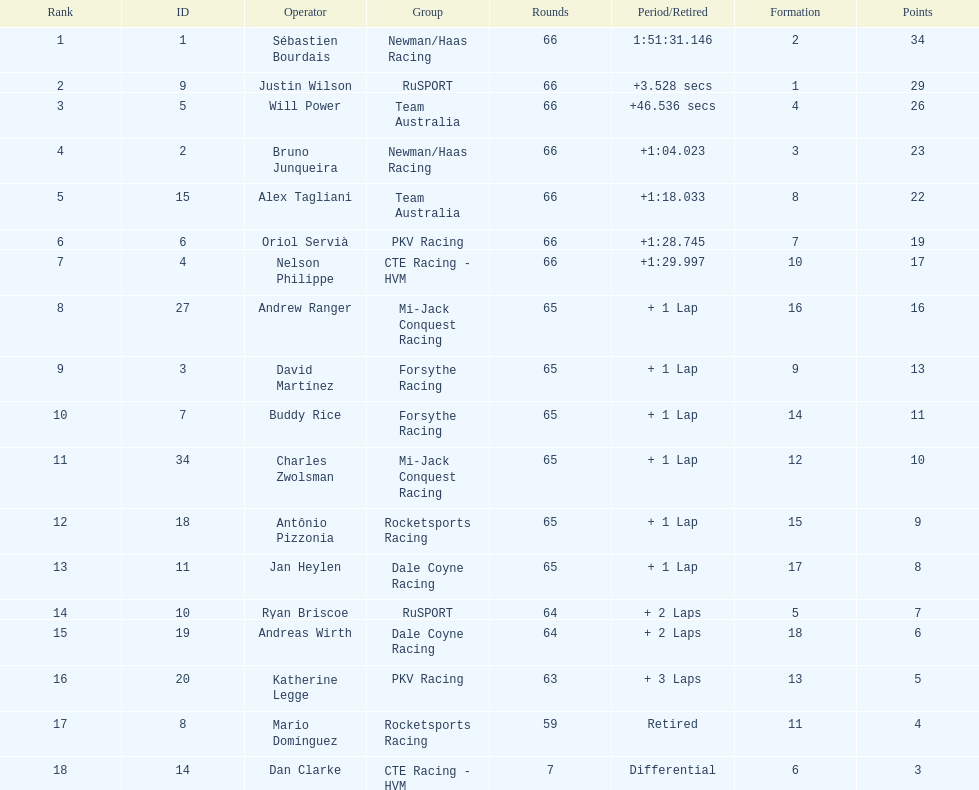Which country is represented by the most drivers? United Kingdom. 